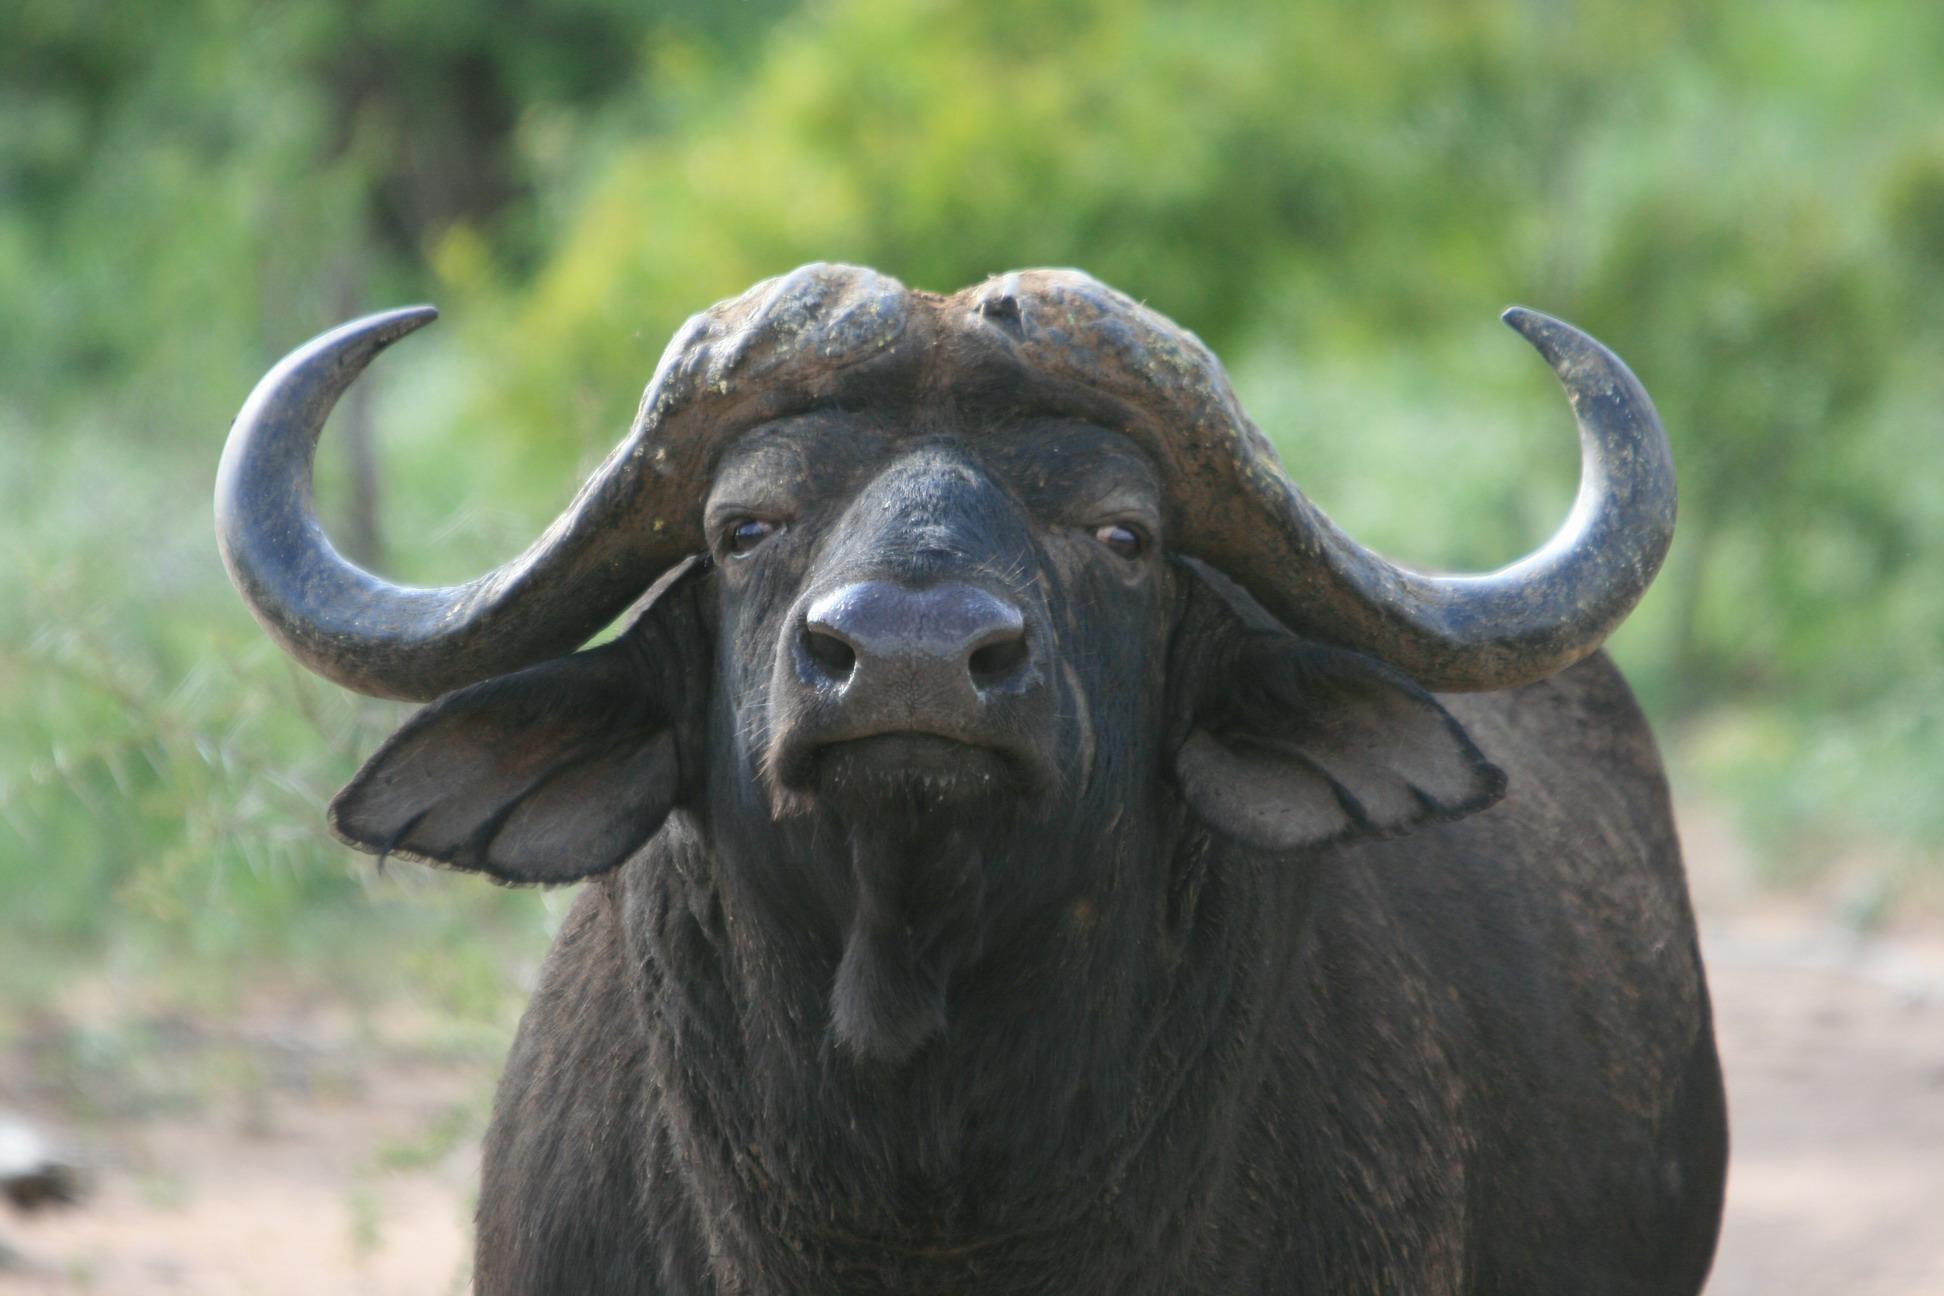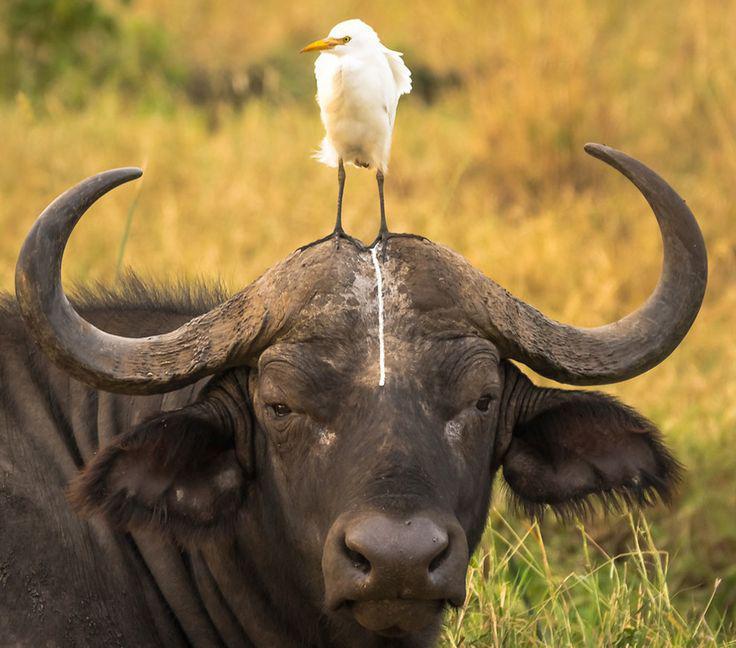The first image is the image on the left, the second image is the image on the right. Examine the images to the left and right. Is the description "Every animal has horns and none has a bird on its head." accurate? Answer yes or no. No. The first image is the image on the left, the second image is the image on the right. Analyze the images presented: Is the assertion "The animal in the image on the left is turned directly toward the camera" valid? Answer yes or no. Yes. 